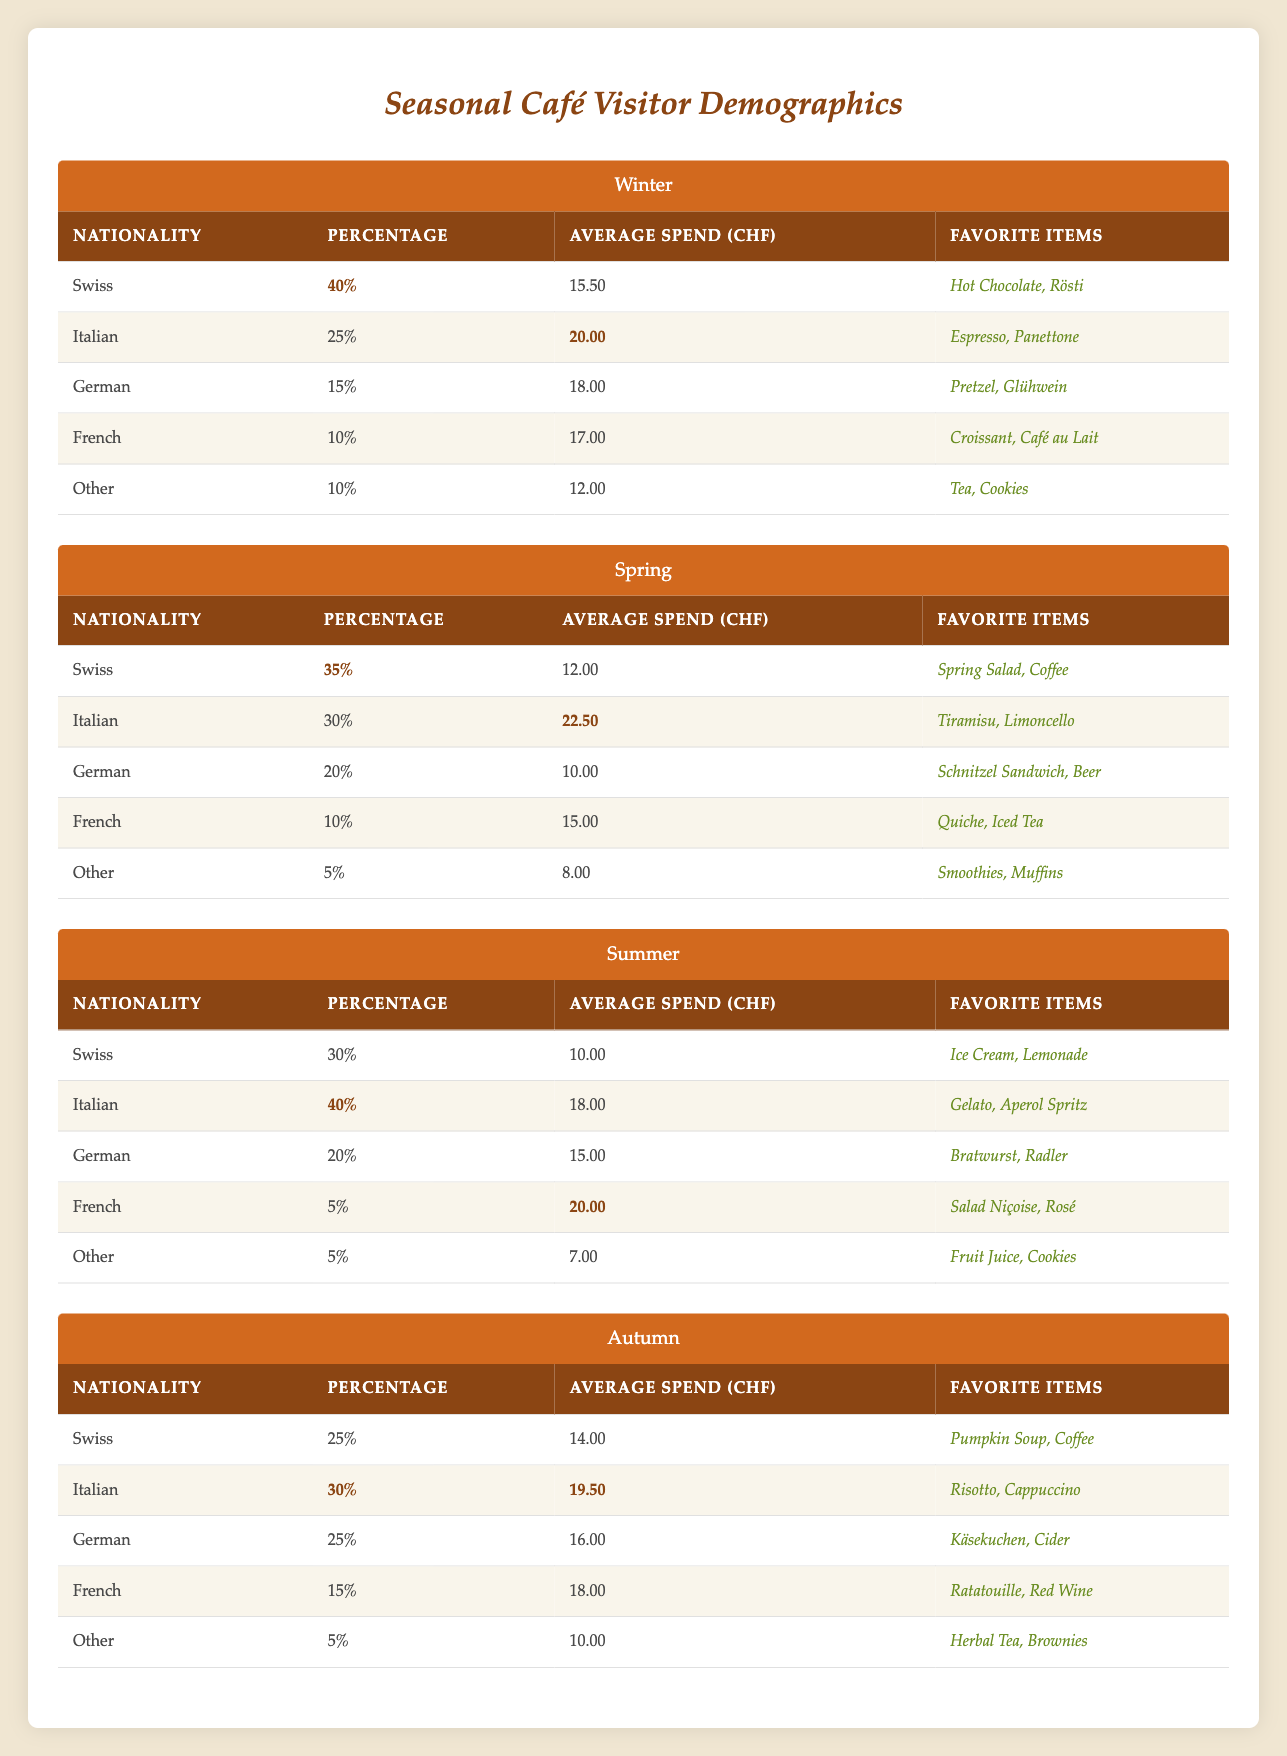What is the nationality with the highest percentage of visitors in Winter? According to the table, the Swiss have the highest percentage of visitors in Winter, which is 40%.
Answer: Swiss Which nationality has the highest average spend in Spring? In Spring, the Italian visitors have the highest average spend at CHF 22.50.
Answer: Italian What is the total percentage of visitors from German and French nationalities in Summer? For Summer, German visitors represent 20% and French visitors represent 5%, so their total percentage is 20% + 5% = 25%.
Answer: 25% What percentage of visitors are categorized as "Other" in Autumn? In Autumn, the visitors labeled as "Other" comprise 5% of the total visitors.
Answer: 5% Which nationality spends less on average, Swiss visitors in Winter or German visitors in Summer? Swiss visitors in Winter spend CHF 15.50 while German visitors in Summer spend CHF 15.00. German visitors spend less, as CHF 15.00 is less than CHF 15.50.
Answer: German visitors in Summer How does the average spend of Italian visitors compare between Winter and Autumn? In Winter, Italian visitors spend CHF 20.00 on average, while in Autumn, they spend CHF 19.50. Winter's average spend is higher, as CHF 20.00 is greater than CHF 19.50.
Answer: Higher in Winter What is the favorite item of Swiss visitors during the Spring season? In Spring, Swiss visitors' favorite items are Spring Salad and Coffee, as indicated in the table.
Answer: Spring Salad, Coffee What nationality has a higher representation during Summer: Italians or Germans? In Summer, Italians represent 40% of the visitors while Germans represent 20%. Since 40% is greater than 20%, Italians have a higher representation.
Answer: Italians Are there more visitors in Winter or Spring? In Winter, Swiss visitors constitute 40%, Italians 25%, Germans 15%, French 10%, and Others 10%, totaling 100%. In Spring, Swiss visitors total 35%, Italians 30%, Germans 20%, French 10%, and Others 5%, also totaling 100%. The percentages are equal, indicating the same number of visitors.
Answer: Equal visitor count Calculate the average spend of German visitors across all seasons. The average spend of German visitors per season is as follows: Winter CHF 18.00, Spring CHF 10.00, Summer CHF 15.00, and Autumn CHF 16.00. The total is 18 + 10 + 15 + 16 = 59, and there are 4 data points. Thus, the average spend is 59 / 4 = 14.75.
Answer: 14.75 What is the change in percentage of Italian visitors from Winter to Summer? In Winter, Italian visitors are at 25% and in Summer, they rise to 40%. The change is 40% - 25% = 15%.
Answer: Increase of 15% 